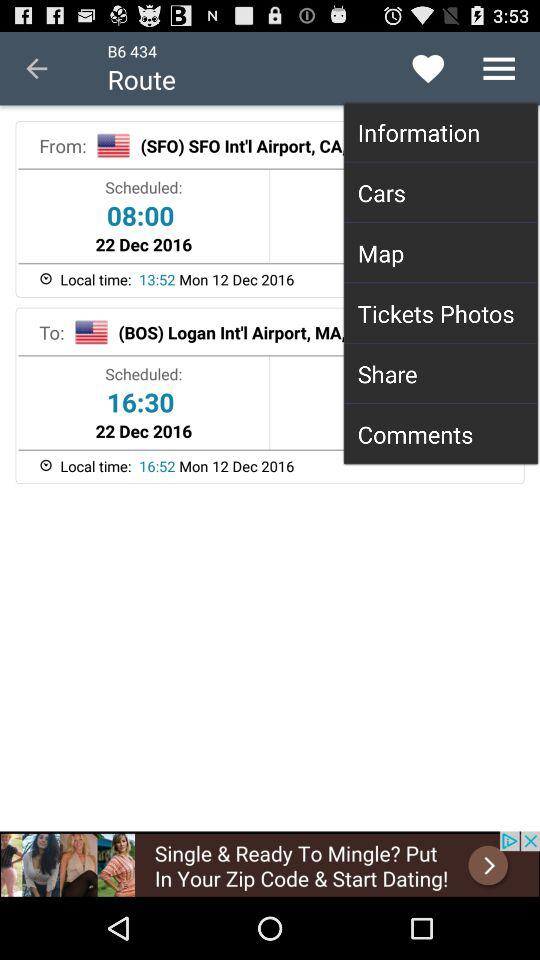What is the destination location?
When the provided information is insufficient, respond with <no answer>. <no answer> 